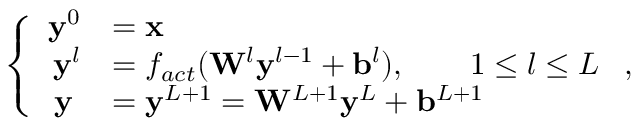<formula> <loc_0><loc_0><loc_500><loc_500>\left \{ \begin{array} { r l } { y ^ { 0 } } & { = x } \\ { y ^ { l } } & { = f _ { a c t } ( W ^ { l } y ^ { l - 1 } + b ^ { l } ) , \quad 1 \leq l \leq L } \\ { y \, } & { = y ^ { L + 1 } = W ^ { L + 1 } y ^ { L } + b ^ { L + 1 } } \end{array} ,</formula> 